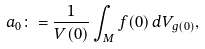<formula> <loc_0><loc_0><loc_500><loc_500>a _ { 0 } \colon = \frac { 1 } { V ( 0 ) } \int _ { M } f ( 0 ) \, d V _ { g ( 0 ) } ,</formula> 